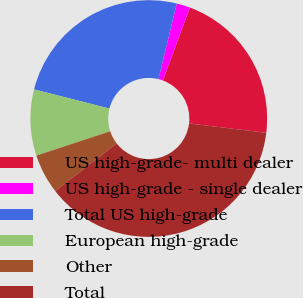Convert chart. <chart><loc_0><loc_0><loc_500><loc_500><pie_chart><fcel>US high-grade- multi dealer<fcel>US high-grade - single dealer<fcel>Total US high-grade<fcel>European high-grade<fcel>Other<fcel>Total<nl><fcel>21.28%<fcel>1.84%<fcel>24.85%<fcel>9.03%<fcel>5.43%<fcel>37.57%<nl></chart> 